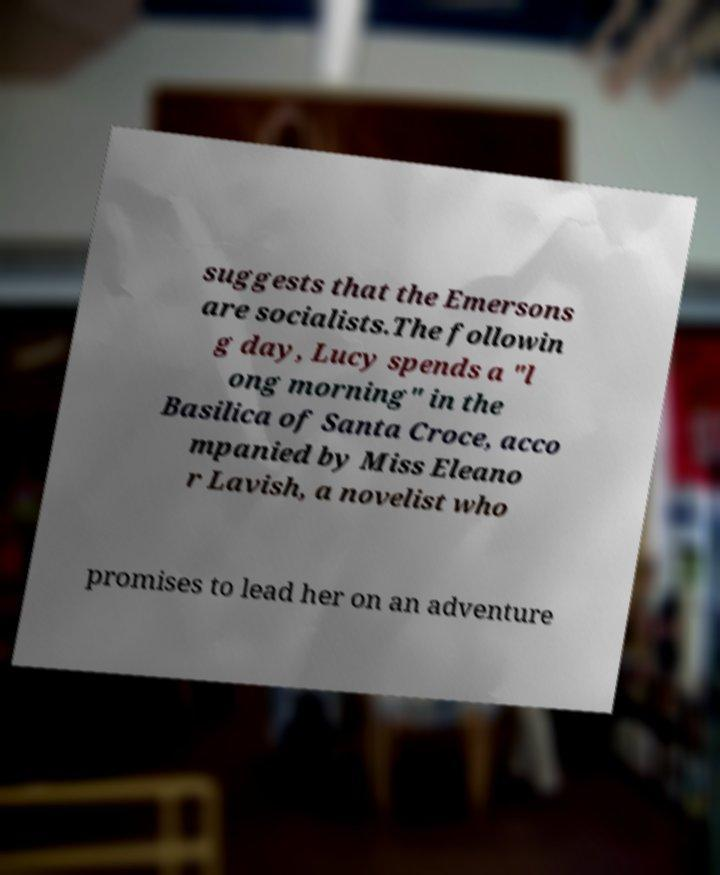Can you read and provide the text displayed in the image?This photo seems to have some interesting text. Can you extract and type it out for me? suggests that the Emersons are socialists.The followin g day, Lucy spends a "l ong morning" in the Basilica of Santa Croce, acco mpanied by Miss Eleano r Lavish, a novelist who promises to lead her on an adventure 